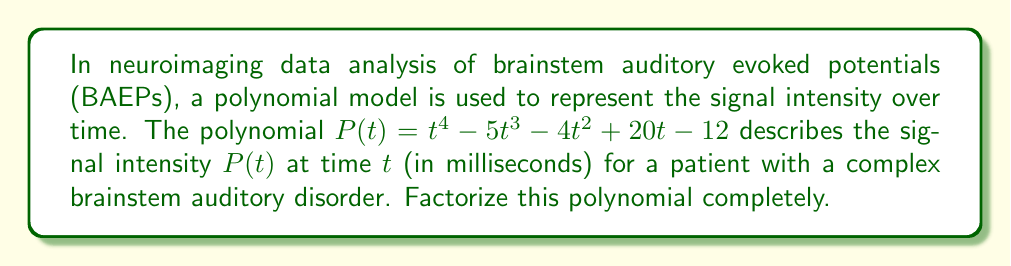Show me your answer to this math problem. To factorize this higher-degree polynomial, we'll follow these steps:

1) First, let's check if there are any rational roots using the rational root theorem. The possible rational roots are the factors of the constant term: ±1, ±2, ±3, ±4, ±6, ±12.

2) Testing these values, we find that $t = 1$ and $t = 3$ are roots of the polynomial.

3) We can factor out $(t-1)$ and $(t-3)$:

   $P(t) = (t-1)(t-3)(at^2 + bt + c)$

4) Expanding this and comparing coefficients with the original polynomial, we can find $a$, $b$, and $c$:

   $P(t) = (t-1)(t-3)(t^2 + at + b)$

5) Expanding further:

   $P(t) = t^4 + (a-4)t^3 + (b-3a+3)t^2 + (-3b+a)t - b$

6) Comparing coefficients with the original polynomial:

   $a-4 = -5$
   $b-3a+3 = -4$
   $-3b+a = 20$
   $-b = -12$

7) Solving this system of equations:

   $a = -1$
   $b = 12$

8) Therefore, the complete factorization is:

   $P(t) = (t-1)(t-3)(t^2 - t + 4)$

9) The quadratic factor $t^2 - t + 4$ cannot be factored further over the real numbers, as its discriminant is negative: $b^2 - 4ac = (-1)^2 - 4(1)(4) = -15 < 0$.
Answer: $P(t) = (t-1)(t-3)(t^2 - t + 4)$ 